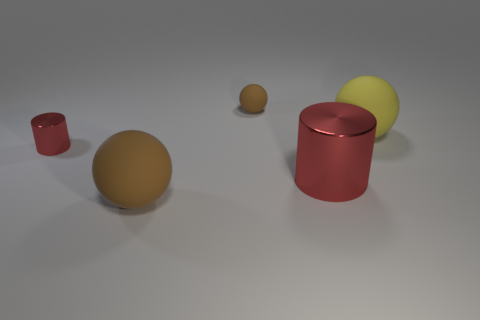Add 2 metal cylinders. How many objects exist? 7 Subtract all spheres. How many objects are left? 2 Add 5 yellow balls. How many yellow balls are left? 6 Add 2 rubber balls. How many rubber balls exist? 5 Subtract 0 gray spheres. How many objects are left? 5 Subtract all big brown rubber spheres. Subtract all red rubber things. How many objects are left? 4 